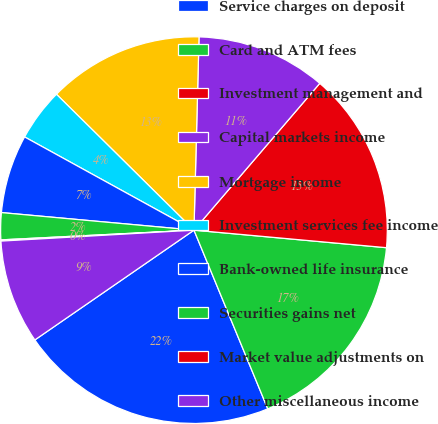<chart> <loc_0><loc_0><loc_500><loc_500><pie_chart><fcel>Service charges on deposit<fcel>Card and ATM fees<fcel>Investment management and<fcel>Capital markets income<fcel>Mortgage income<fcel>Investment services fee income<fcel>Bank-owned life insurance<fcel>Securities gains net<fcel>Market value adjustments on<fcel>Other miscellaneous income<nl><fcel>21.62%<fcel>17.32%<fcel>15.17%<fcel>10.86%<fcel>13.01%<fcel>4.4%<fcel>6.56%<fcel>2.25%<fcel>0.1%<fcel>8.71%<nl></chart> 